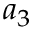Convert formula to latex. <formula><loc_0><loc_0><loc_500><loc_500>a _ { 3 }</formula> 